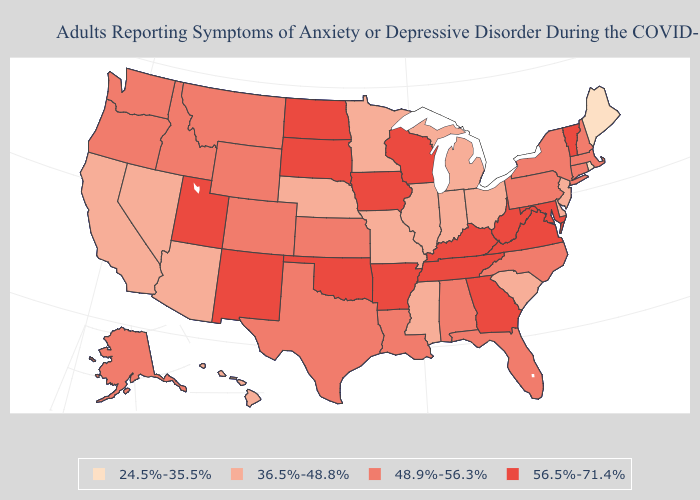What is the highest value in the USA?
Be succinct. 56.5%-71.4%. Name the states that have a value in the range 48.9%-56.3%?
Short answer required. Alabama, Alaska, Colorado, Connecticut, Florida, Idaho, Kansas, Louisiana, Massachusetts, Montana, New Hampshire, New York, North Carolina, Oregon, Pennsylvania, Texas, Washington, Wyoming. Which states have the lowest value in the South?
Concise answer only. Delaware, Mississippi, South Carolina. Does the first symbol in the legend represent the smallest category?
Quick response, please. Yes. How many symbols are there in the legend?
Concise answer only. 4. What is the highest value in the South ?
Quick response, please. 56.5%-71.4%. Name the states that have a value in the range 36.5%-48.8%?
Concise answer only. Arizona, California, Delaware, Hawaii, Illinois, Indiana, Michigan, Minnesota, Mississippi, Missouri, Nebraska, Nevada, New Jersey, Ohio, South Carolina. Which states have the highest value in the USA?
Give a very brief answer. Arkansas, Georgia, Iowa, Kentucky, Maryland, New Mexico, North Dakota, Oklahoma, South Dakota, Tennessee, Utah, Vermont, Virginia, West Virginia, Wisconsin. Which states hav the highest value in the South?
Give a very brief answer. Arkansas, Georgia, Kentucky, Maryland, Oklahoma, Tennessee, Virginia, West Virginia. Does the map have missing data?
Give a very brief answer. No. Name the states that have a value in the range 48.9%-56.3%?
Give a very brief answer. Alabama, Alaska, Colorado, Connecticut, Florida, Idaho, Kansas, Louisiana, Massachusetts, Montana, New Hampshire, New York, North Carolina, Oregon, Pennsylvania, Texas, Washington, Wyoming. What is the value of Oklahoma?
Short answer required. 56.5%-71.4%. Does Vermont have the lowest value in the Northeast?
Quick response, please. No. Does Washington have the lowest value in the USA?
Keep it brief. No. Name the states that have a value in the range 36.5%-48.8%?
Give a very brief answer. Arizona, California, Delaware, Hawaii, Illinois, Indiana, Michigan, Minnesota, Mississippi, Missouri, Nebraska, Nevada, New Jersey, Ohio, South Carolina. 